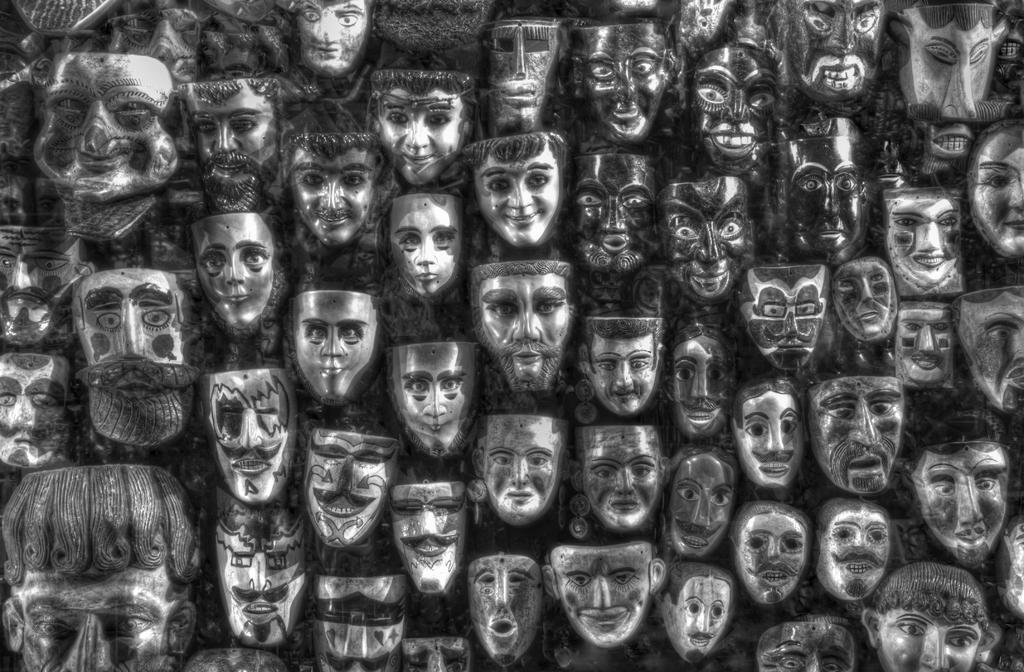What type of protective gear can be seen in the image? Face masks are visible in the image. What purpose do the face masks serve? Face masks are typically worn to protect oneself and others from the spread of germs or airborne particles. What type of receipt is visible in the image? There is no receipt present in the image; it only features face masks. What type of reaction can be seen on the face masks in the image? There are no faces or expressions visible in the image, as it only features face masks. 